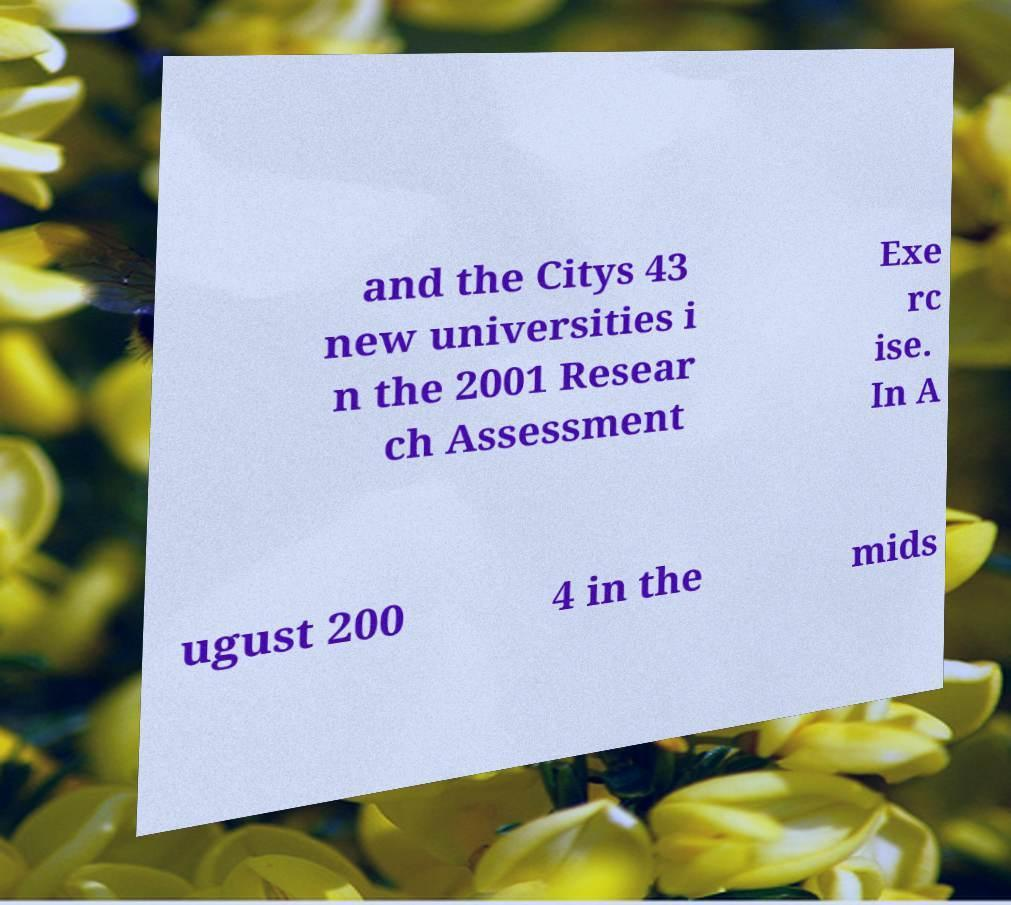Please identify and transcribe the text found in this image. and the Citys 43 new universities i n the 2001 Resear ch Assessment Exe rc ise. In A ugust 200 4 in the mids 